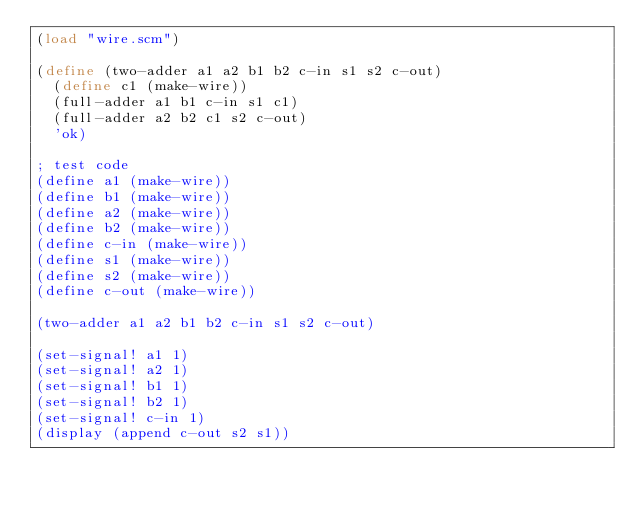<code> <loc_0><loc_0><loc_500><loc_500><_Scheme_>(load "wire.scm")

(define (two-adder a1 a2 b1 b2 c-in s1 s2 c-out)
  (define c1 (make-wire))
  (full-adder a1 b1 c-in s1 c1)
  (full-adder a2 b2 c1 s2 c-out)
  'ok)

; test code
(define a1 (make-wire))
(define b1 (make-wire))
(define a2 (make-wire))
(define b2 (make-wire))
(define c-in (make-wire))
(define s1 (make-wire))
(define s2 (make-wire))
(define c-out (make-wire))

(two-adder a1 a2 b1 b2 c-in s1 s2 c-out)

(set-signal! a1 1)
(set-signal! a2 1)
(set-signal! b1 1)
(set-signal! b2 1)
(set-signal! c-in 1)
(display (append c-out s2 s1))
</code> 